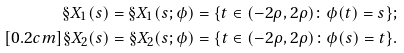<formula> <loc_0><loc_0><loc_500><loc_500>\S X _ { 1 } ( s ) = \S X _ { 1 } ( s ; \phi ) = \{ t \in ( - 2 \rho , 2 \rho ) \colon \phi ( t ) = s \} ; \\ [ 0 . 2 c m ] \S X _ { 2 } ( s ) = \S X _ { 2 } ( s ; \phi ) = \{ t \in ( - 2 \rho , 2 \rho ) \colon \phi ( s ) = t \} .</formula> 